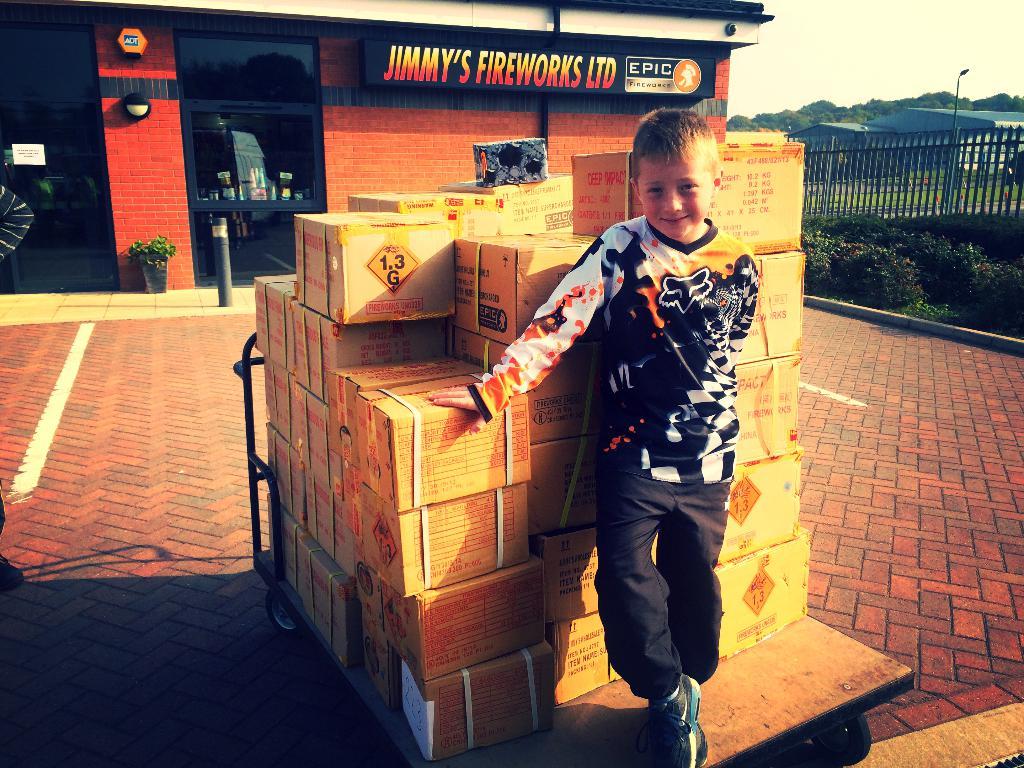What is in the box?
Keep it short and to the point. Fireworks. Whats the name of the company written on the building in the back?
Give a very brief answer. Jimmy's fireworks ltd. 